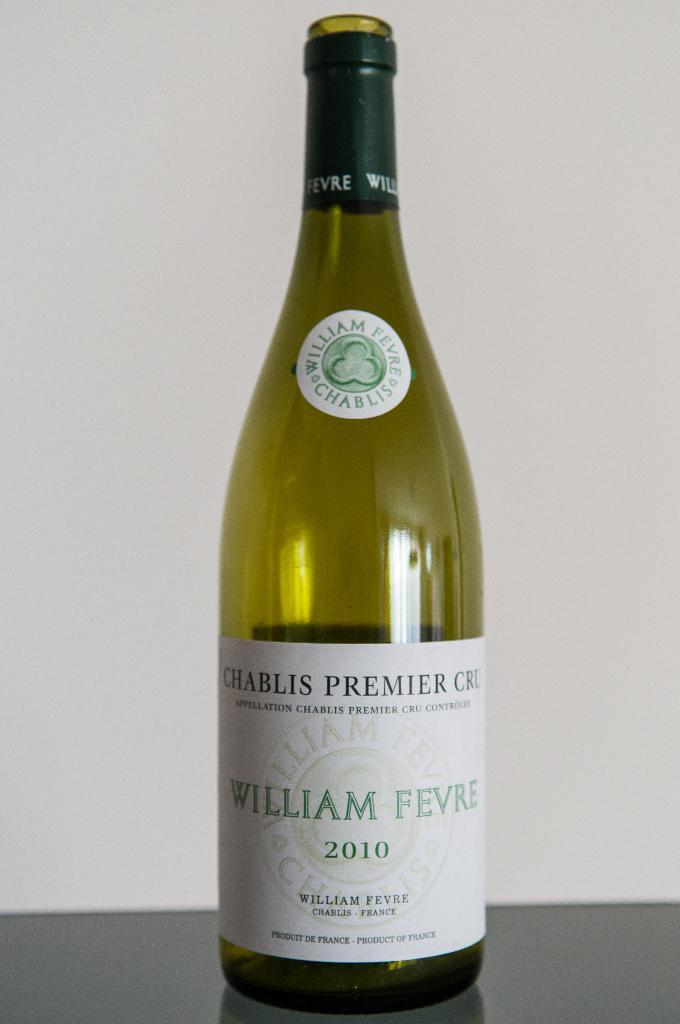From which country that wine come from?
Provide a short and direct response. France. 